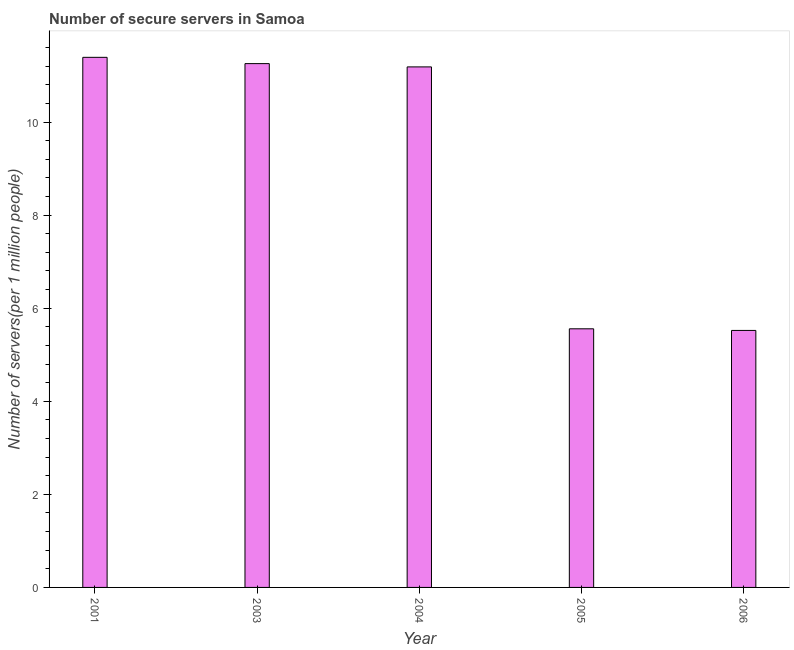Does the graph contain grids?
Offer a terse response. No. What is the title of the graph?
Your answer should be compact. Number of secure servers in Samoa. What is the label or title of the Y-axis?
Make the answer very short. Number of servers(per 1 million people). What is the number of secure internet servers in 2004?
Provide a succinct answer. 11.19. Across all years, what is the maximum number of secure internet servers?
Your answer should be very brief. 11.39. Across all years, what is the minimum number of secure internet servers?
Your answer should be compact. 5.52. In which year was the number of secure internet servers maximum?
Offer a terse response. 2001. In which year was the number of secure internet servers minimum?
Your response must be concise. 2006. What is the sum of the number of secure internet servers?
Keep it short and to the point. 44.91. What is the difference between the number of secure internet servers in 2003 and 2006?
Your answer should be compact. 5.73. What is the average number of secure internet servers per year?
Make the answer very short. 8.98. What is the median number of secure internet servers?
Offer a terse response. 11.19. In how many years, is the number of secure internet servers greater than 7.2 ?
Offer a very short reply. 3. What is the ratio of the number of secure internet servers in 2004 to that in 2005?
Your answer should be compact. 2.01. Is the number of secure internet servers in 2004 less than that in 2005?
Make the answer very short. No. Is the difference between the number of secure internet servers in 2003 and 2006 greater than the difference between any two years?
Make the answer very short. No. What is the difference between the highest and the second highest number of secure internet servers?
Provide a succinct answer. 0.14. What is the difference between the highest and the lowest number of secure internet servers?
Your answer should be compact. 5.87. In how many years, is the number of secure internet servers greater than the average number of secure internet servers taken over all years?
Your answer should be compact. 3. How many bars are there?
Your answer should be compact. 5. How many years are there in the graph?
Keep it short and to the point. 5. What is the difference between two consecutive major ticks on the Y-axis?
Provide a succinct answer. 2. What is the Number of servers(per 1 million people) in 2001?
Offer a terse response. 11.39. What is the Number of servers(per 1 million people) of 2003?
Offer a very short reply. 11.26. What is the Number of servers(per 1 million people) of 2004?
Provide a succinct answer. 11.19. What is the Number of servers(per 1 million people) in 2005?
Offer a terse response. 5.56. What is the Number of servers(per 1 million people) of 2006?
Ensure brevity in your answer.  5.52. What is the difference between the Number of servers(per 1 million people) in 2001 and 2003?
Your answer should be compact. 0.14. What is the difference between the Number of servers(per 1 million people) in 2001 and 2004?
Offer a very short reply. 0.21. What is the difference between the Number of servers(per 1 million people) in 2001 and 2005?
Offer a very short reply. 5.83. What is the difference between the Number of servers(per 1 million people) in 2001 and 2006?
Keep it short and to the point. 5.87. What is the difference between the Number of servers(per 1 million people) in 2003 and 2004?
Keep it short and to the point. 0.07. What is the difference between the Number of servers(per 1 million people) in 2003 and 2005?
Offer a very short reply. 5.7. What is the difference between the Number of servers(per 1 million people) in 2003 and 2006?
Keep it short and to the point. 5.73. What is the difference between the Number of servers(per 1 million people) in 2004 and 2005?
Your response must be concise. 5.63. What is the difference between the Number of servers(per 1 million people) in 2004 and 2006?
Your response must be concise. 5.66. What is the difference between the Number of servers(per 1 million people) in 2005 and 2006?
Ensure brevity in your answer.  0.04. What is the ratio of the Number of servers(per 1 million people) in 2001 to that in 2004?
Provide a succinct answer. 1.02. What is the ratio of the Number of servers(per 1 million people) in 2001 to that in 2005?
Your response must be concise. 2.05. What is the ratio of the Number of servers(per 1 million people) in 2001 to that in 2006?
Ensure brevity in your answer.  2.06. What is the ratio of the Number of servers(per 1 million people) in 2003 to that in 2004?
Offer a terse response. 1.01. What is the ratio of the Number of servers(per 1 million people) in 2003 to that in 2005?
Keep it short and to the point. 2.02. What is the ratio of the Number of servers(per 1 million people) in 2003 to that in 2006?
Offer a very short reply. 2.04. What is the ratio of the Number of servers(per 1 million people) in 2004 to that in 2005?
Offer a terse response. 2.01. What is the ratio of the Number of servers(per 1 million people) in 2004 to that in 2006?
Offer a terse response. 2.02. What is the ratio of the Number of servers(per 1 million people) in 2005 to that in 2006?
Ensure brevity in your answer.  1.01. 